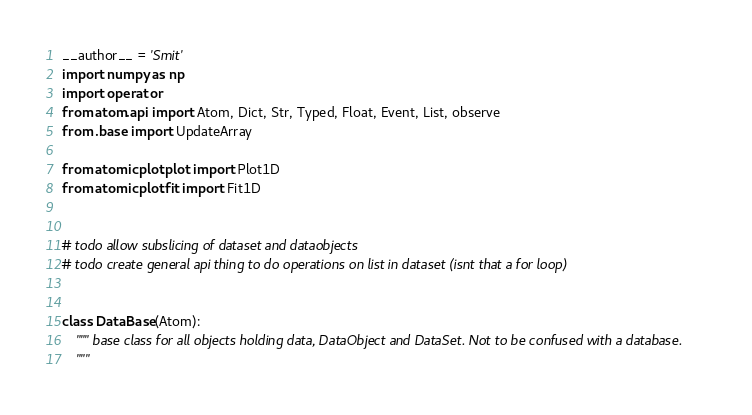<code> <loc_0><loc_0><loc_500><loc_500><_Python_>__author__ = 'Smit'
import numpy as np
import operator
from atom.api import Atom, Dict, Str, Typed, Float, Event, List, observe
from .base import UpdateArray

from atomicplot.plot import Plot1D
from atomicplot.fit import Fit1D


# todo allow subslicing of dataset and dataobjects
# todo create general api thing to do operations on list in dataset (isnt that a for loop)


class DataBase(Atom):
    """ base class for all objects holding data, DataObject and DataSet. Not to be confused with a database.
    """
</code> 